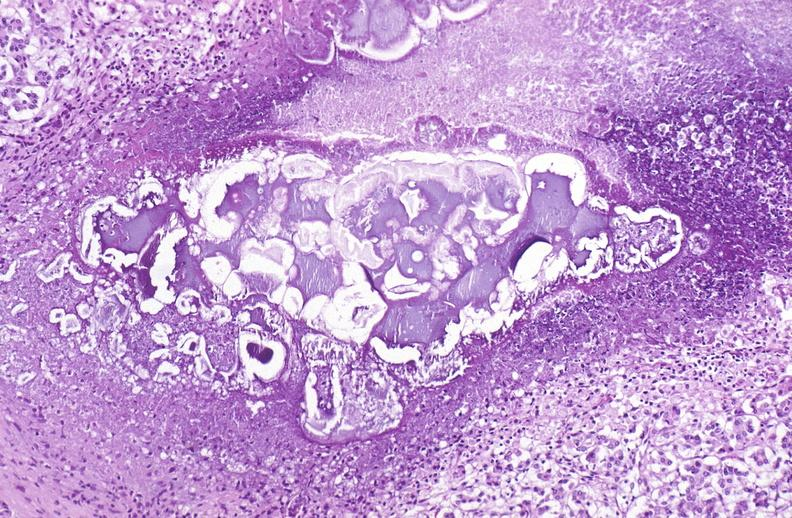what does this image show?
Answer the question using a single word or phrase. Pancreatic fat necrosis 